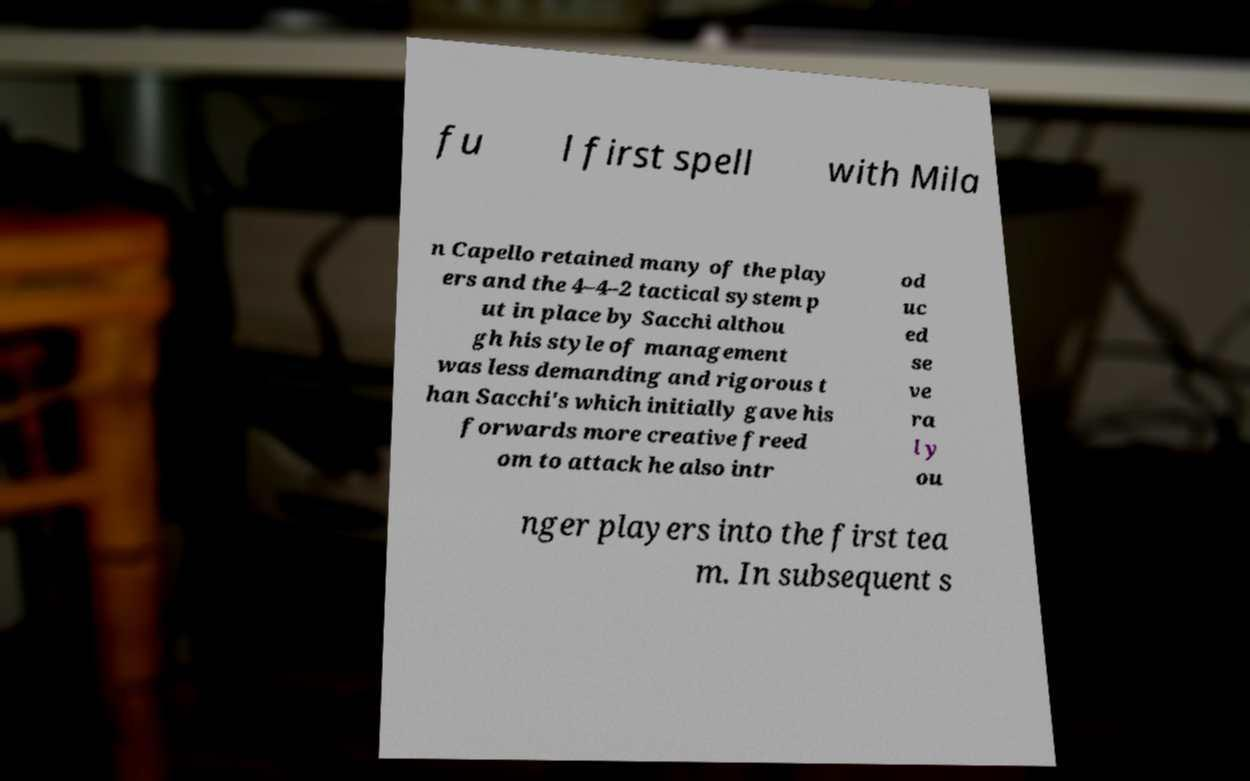Could you extract and type out the text from this image? fu l first spell with Mila n Capello retained many of the play ers and the 4–4–2 tactical system p ut in place by Sacchi althou gh his style of management was less demanding and rigorous t han Sacchi's which initially gave his forwards more creative freed om to attack he also intr od uc ed se ve ra l y ou nger players into the first tea m. In subsequent s 